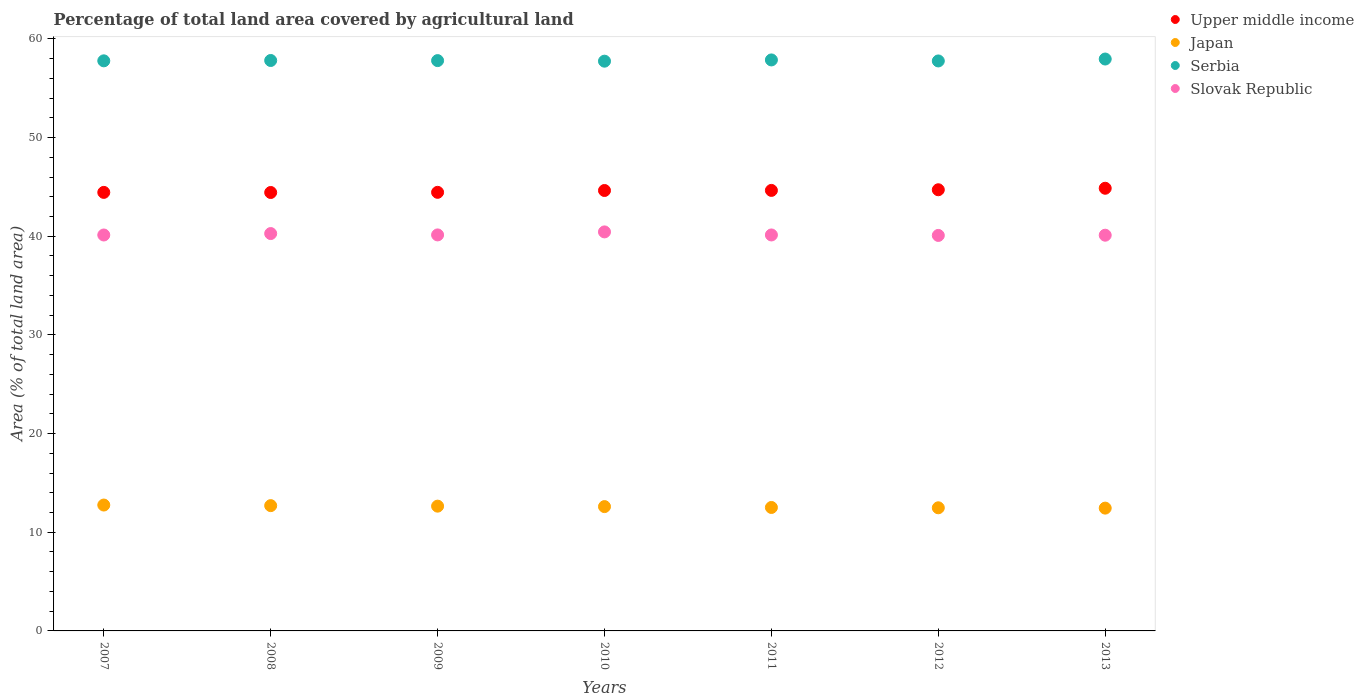How many different coloured dotlines are there?
Your answer should be compact. 4. What is the percentage of agricultural land in Upper middle income in 2012?
Offer a very short reply. 44.71. Across all years, what is the maximum percentage of agricultural land in Serbia?
Keep it short and to the point. 57.96. Across all years, what is the minimum percentage of agricultural land in Japan?
Make the answer very short. 12.45. What is the total percentage of agricultural land in Upper middle income in the graph?
Your answer should be compact. 312.17. What is the difference between the percentage of agricultural land in Slovak Republic in 2007 and that in 2008?
Give a very brief answer. -0.15. What is the difference between the percentage of agricultural land in Slovak Republic in 2008 and the percentage of agricultural land in Upper middle income in 2012?
Your answer should be compact. -4.44. What is the average percentage of agricultural land in Serbia per year?
Provide a succinct answer. 57.82. In the year 2013, what is the difference between the percentage of agricultural land in Serbia and percentage of agricultural land in Slovak Republic?
Make the answer very short. 17.85. What is the ratio of the percentage of agricultural land in Upper middle income in 2009 to that in 2013?
Your answer should be very brief. 0.99. What is the difference between the highest and the second highest percentage of agricultural land in Upper middle income?
Offer a very short reply. 0.15. What is the difference between the highest and the lowest percentage of agricultural land in Slovak Republic?
Give a very brief answer. 0.36. Is it the case that in every year, the sum of the percentage of agricultural land in Slovak Republic and percentage of agricultural land in Japan  is greater than the sum of percentage of agricultural land in Serbia and percentage of agricultural land in Upper middle income?
Make the answer very short. No. Does the percentage of agricultural land in Serbia monotonically increase over the years?
Keep it short and to the point. No. Is the percentage of agricultural land in Upper middle income strictly greater than the percentage of agricultural land in Serbia over the years?
Offer a very short reply. No. Is the percentage of agricultural land in Upper middle income strictly less than the percentage of agricultural land in Japan over the years?
Offer a very short reply. No. How many dotlines are there?
Make the answer very short. 4. What is the difference between two consecutive major ticks on the Y-axis?
Offer a very short reply. 10. Where does the legend appear in the graph?
Offer a very short reply. Top right. How many legend labels are there?
Provide a short and direct response. 4. What is the title of the graph?
Your answer should be very brief. Percentage of total land area covered by agricultural land. Does "Macedonia" appear as one of the legend labels in the graph?
Give a very brief answer. No. What is the label or title of the X-axis?
Your response must be concise. Years. What is the label or title of the Y-axis?
Give a very brief answer. Area (% of total land area). What is the Area (% of total land area) of Upper middle income in 2007?
Your answer should be compact. 44.44. What is the Area (% of total land area) in Japan in 2007?
Make the answer very short. 12.76. What is the Area (% of total land area) of Serbia in 2007?
Your answer should be compact. 57.77. What is the Area (% of total land area) of Slovak Republic in 2007?
Provide a succinct answer. 40.12. What is the Area (% of total land area) in Upper middle income in 2008?
Provide a succinct answer. 44.43. What is the Area (% of total land area) of Japan in 2008?
Your response must be concise. 12.7. What is the Area (% of total land area) of Serbia in 2008?
Offer a very short reply. 57.81. What is the Area (% of total land area) of Slovak Republic in 2008?
Your answer should be very brief. 40.27. What is the Area (% of total land area) of Upper middle income in 2009?
Ensure brevity in your answer.  44.45. What is the Area (% of total land area) in Japan in 2009?
Provide a short and direct response. 12.64. What is the Area (% of total land area) in Serbia in 2009?
Ensure brevity in your answer.  57.8. What is the Area (% of total land area) in Slovak Republic in 2009?
Your answer should be very brief. 40.13. What is the Area (% of total land area) in Upper middle income in 2010?
Make the answer very short. 44.63. What is the Area (% of total land area) of Japan in 2010?
Offer a very short reply. 12.6. What is the Area (% of total land area) in Serbia in 2010?
Your answer should be very brief. 57.74. What is the Area (% of total land area) of Slovak Republic in 2010?
Your response must be concise. 40.44. What is the Area (% of total land area) of Upper middle income in 2011?
Your answer should be very brief. 44.64. What is the Area (% of total land area) of Japan in 2011?
Offer a terse response. 12.51. What is the Area (% of total land area) of Serbia in 2011?
Keep it short and to the point. 57.87. What is the Area (% of total land area) of Slovak Republic in 2011?
Your answer should be very brief. 40.13. What is the Area (% of total land area) of Upper middle income in 2012?
Give a very brief answer. 44.71. What is the Area (% of total land area) in Japan in 2012?
Ensure brevity in your answer.  12.48. What is the Area (% of total land area) of Serbia in 2012?
Ensure brevity in your answer.  57.76. What is the Area (% of total land area) in Slovak Republic in 2012?
Ensure brevity in your answer.  40.08. What is the Area (% of total land area) of Upper middle income in 2013?
Give a very brief answer. 44.86. What is the Area (% of total land area) of Japan in 2013?
Offer a very short reply. 12.45. What is the Area (% of total land area) of Serbia in 2013?
Provide a succinct answer. 57.96. What is the Area (% of total land area) of Slovak Republic in 2013?
Make the answer very short. 40.1. Across all years, what is the maximum Area (% of total land area) in Upper middle income?
Provide a succinct answer. 44.86. Across all years, what is the maximum Area (% of total land area) in Japan?
Offer a very short reply. 12.76. Across all years, what is the maximum Area (% of total land area) in Serbia?
Provide a short and direct response. 57.96. Across all years, what is the maximum Area (% of total land area) of Slovak Republic?
Keep it short and to the point. 40.44. Across all years, what is the minimum Area (% of total land area) of Upper middle income?
Give a very brief answer. 44.43. Across all years, what is the minimum Area (% of total land area) in Japan?
Ensure brevity in your answer.  12.45. Across all years, what is the minimum Area (% of total land area) in Serbia?
Ensure brevity in your answer.  57.74. Across all years, what is the minimum Area (% of total land area) of Slovak Republic?
Ensure brevity in your answer.  40.08. What is the total Area (% of total land area) in Upper middle income in the graph?
Provide a succinct answer. 312.17. What is the total Area (% of total land area) of Japan in the graph?
Keep it short and to the point. 88.13. What is the total Area (% of total land area) of Serbia in the graph?
Make the answer very short. 404.71. What is the total Area (% of total land area) of Slovak Republic in the graph?
Ensure brevity in your answer.  281.28. What is the difference between the Area (% of total land area) in Upper middle income in 2007 and that in 2008?
Provide a short and direct response. 0.01. What is the difference between the Area (% of total land area) of Japan in 2007 and that in 2008?
Your answer should be compact. 0.06. What is the difference between the Area (% of total land area) in Serbia in 2007 and that in 2008?
Your answer should be compact. -0.03. What is the difference between the Area (% of total land area) of Slovak Republic in 2007 and that in 2008?
Keep it short and to the point. -0.15. What is the difference between the Area (% of total land area) in Upper middle income in 2007 and that in 2009?
Provide a succinct answer. -0.01. What is the difference between the Area (% of total land area) in Japan in 2007 and that in 2009?
Provide a short and direct response. 0.11. What is the difference between the Area (% of total land area) of Serbia in 2007 and that in 2009?
Your response must be concise. -0.02. What is the difference between the Area (% of total land area) in Slovak Republic in 2007 and that in 2009?
Keep it short and to the point. -0.01. What is the difference between the Area (% of total land area) in Upper middle income in 2007 and that in 2010?
Offer a terse response. -0.19. What is the difference between the Area (% of total land area) in Japan in 2007 and that in 2010?
Give a very brief answer. 0.16. What is the difference between the Area (% of total land area) in Serbia in 2007 and that in 2010?
Your response must be concise. 0.03. What is the difference between the Area (% of total land area) in Slovak Republic in 2007 and that in 2010?
Your response must be concise. -0.31. What is the difference between the Area (% of total land area) of Upper middle income in 2007 and that in 2011?
Provide a succinct answer. -0.2. What is the difference between the Area (% of total land area) in Japan in 2007 and that in 2011?
Ensure brevity in your answer.  0.25. What is the difference between the Area (% of total land area) of Serbia in 2007 and that in 2011?
Your answer should be compact. -0.09. What is the difference between the Area (% of total land area) of Slovak Republic in 2007 and that in 2011?
Provide a succinct answer. -0. What is the difference between the Area (% of total land area) of Upper middle income in 2007 and that in 2012?
Your response must be concise. -0.27. What is the difference between the Area (% of total land area) of Japan in 2007 and that in 2012?
Offer a terse response. 0.28. What is the difference between the Area (% of total land area) in Serbia in 2007 and that in 2012?
Give a very brief answer. 0.01. What is the difference between the Area (% of total land area) in Slovak Republic in 2007 and that in 2012?
Your response must be concise. 0.04. What is the difference between the Area (% of total land area) in Upper middle income in 2007 and that in 2013?
Ensure brevity in your answer.  -0.42. What is the difference between the Area (% of total land area) in Japan in 2007 and that in 2013?
Offer a very short reply. 0.31. What is the difference between the Area (% of total land area) in Serbia in 2007 and that in 2013?
Your answer should be very brief. -0.18. What is the difference between the Area (% of total land area) in Slovak Republic in 2007 and that in 2013?
Make the answer very short. 0.02. What is the difference between the Area (% of total land area) of Upper middle income in 2008 and that in 2009?
Provide a succinct answer. -0.02. What is the difference between the Area (% of total land area) in Japan in 2008 and that in 2009?
Provide a succinct answer. 0.05. What is the difference between the Area (% of total land area) of Serbia in 2008 and that in 2009?
Your answer should be very brief. 0.01. What is the difference between the Area (% of total land area) in Slovak Republic in 2008 and that in 2009?
Your answer should be very brief. 0.14. What is the difference between the Area (% of total land area) in Upper middle income in 2008 and that in 2010?
Offer a very short reply. -0.2. What is the difference between the Area (% of total land area) of Japan in 2008 and that in 2010?
Keep it short and to the point. 0.1. What is the difference between the Area (% of total land area) in Serbia in 2008 and that in 2010?
Offer a very short reply. 0.07. What is the difference between the Area (% of total land area) in Slovak Republic in 2008 and that in 2010?
Give a very brief answer. -0.17. What is the difference between the Area (% of total land area) of Upper middle income in 2008 and that in 2011?
Your answer should be very brief. -0.21. What is the difference between the Area (% of total land area) of Japan in 2008 and that in 2011?
Ensure brevity in your answer.  0.19. What is the difference between the Area (% of total land area) in Serbia in 2008 and that in 2011?
Give a very brief answer. -0.06. What is the difference between the Area (% of total land area) of Slovak Republic in 2008 and that in 2011?
Your answer should be very brief. 0.14. What is the difference between the Area (% of total land area) of Upper middle income in 2008 and that in 2012?
Give a very brief answer. -0.28. What is the difference between the Area (% of total land area) in Japan in 2008 and that in 2012?
Your answer should be compact. 0.22. What is the difference between the Area (% of total land area) in Serbia in 2008 and that in 2012?
Give a very brief answer. 0.05. What is the difference between the Area (% of total land area) in Slovak Republic in 2008 and that in 2012?
Your answer should be very brief. 0.19. What is the difference between the Area (% of total land area) in Upper middle income in 2008 and that in 2013?
Provide a short and direct response. -0.43. What is the difference between the Area (% of total land area) of Japan in 2008 and that in 2013?
Offer a terse response. 0.25. What is the difference between the Area (% of total land area) in Serbia in 2008 and that in 2013?
Your answer should be very brief. -0.15. What is the difference between the Area (% of total land area) of Slovak Republic in 2008 and that in 2013?
Offer a very short reply. 0.17. What is the difference between the Area (% of total land area) of Upper middle income in 2009 and that in 2010?
Make the answer very short. -0.19. What is the difference between the Area (% of total land area) of Japan in 2009 and that in 2010?
Provide a succinct answer. 0.05. What is the difference between the Area (% of total land area) of Serbia in 2009 and that in 2010?
Offer a terse response. 0.06. What is the difference between the Area (% of total land area) of Slovak Republic in 2009 and that in 2010?
Give a very brief answer. -0.3. What is the difference between the Area (% of total land area) in Upper middle income in 2009 and that in 2011?
Ensure brevity in your answer.  -0.2. What is the difference between the Area (% of total land area) of Japan in 2009 and that in 2011?
Your answer should be compact. 0.13. What is the difference between the Area (% of total land area) in Serbia in 2009 and that in 2011?
Offer a very short reply. -0.07. What is the difference between the Area (% of total land area) in Slovak Republic in 2009 and that in 2011?
Ensure brevity in your answer.  0. What is the difference between the Area (% of total land area) in Upper middle income in 2009 and that in 2012?
Offer a very short reply. -0.26. What is the difference between the Area (% of total land area) of Serbia in 2009 and that in 2012?
Your answer should be compact. 0.03. What is the difference between the Area (% of total land area) in Slovak Republic in 2009 and that in 2012?
Give a very brief answer. 0.05. What is the difference between the Area (% of total land area) in Upper middle income in 2009 and that in 2013?
Your response must be concise. -0.41. What is the difference between the Area (% of total land area) of Japan in 2009 and that in 2013?
Ensure brevity in your answer.  0.2. What is the difference between the Area (% of total land area) in Serbia in 2009 and that in 2013?
Ensure brevity in your answer.  -0.16. What is the difference between the Area (% of total land area) in Slovak Republic in 2009 and that in 2013?
Your answer should be very brief. 0.03. What is the difference between the Area (% of total land area) in Upper middle income in 2010 and that in 2011?
Offer a terse response. -0.01. What is the difference between the Area (% of total land area) of Japan in 2010 and that in 2011?
Keep it short and to the point. 0.09. What is the difference between the Area (% of total land area) of Serbia in 2010 and that in 2011?
Offer a very short reply. -0.13. What is the difference between the Area (% of total land area) of Slovak Republic in 2010 and that in 2011?
Make the answer very short. 0.31. What is the difference between the Area (% of total land area) of Upper middle income in 2010 and that in 2012?
Your response must be concise. -0.08. What is the difference between the Area (% of total land area) of Japan in 2010 and that in 2012?
Provide a short and direct response. 0.12. What is the difference between the Area (% of total land area) of Serbia in 2010 and that in 2012?
Ensure brevity in your answer.  -0.02. What is the difference between the Area (% of total land area) in Slovak Republic in 2010 and that in 2012?
Your response must be concise. 0.36. What is the difference between the Area (% of total land area) of Upper middle income in 2010 and that in 2013?
Offer a very short reply. -0.23. What is the difference between the Area (% of total land area) in Japan in 2010 and that in 2013?
Keep it short and to the point. 0.15. What is the difference between the Area (% of total land area) in Serbia in 2010 and that in 2013?
Give a very brief answer. -0.22. What is the difference between the Area (% of total land area) of Slovak Republic in 2010 and that in 2013?
Your answer should be compact. 0.33. What is the difference between the Area (% of total land area) of Upper middle income in 2011 and that in 2012?
Provide a short and direct response. -0.07. What is the difference between the Area (% of total land area) of Japan in 2011 and that in 2012?
Ensure brevity in your answer.  0.03. What is the difference between the Area (% of total land area) in Serbia in 2011 and that in 2012?
Ensure brevity in your answer.  0.1. What is the difference between the Area (% of total land area) of Slovak Republic in 2011 and that in 2012?
Your response must be concise. 0.05. What is the difference between the Area (% of total land area) of Upper middle income in 2011 and that in 2013?
Your response must be concise. -0.22. What is the difference between the Area (% of total land area) in Japan in 2011 and that in 2013?
Make the answer very short. 0.07. What is the difference between the Area (% of total land area) in Serbia in 2011 and that in 2013?
Give a very brief answer. -0.09. What is the difference between the Area (% of total land area) in Slovak Republic in 2011 and that in 2013?
Give a very brief answer. 0.03. What is the difference between the Area (% of total land area) in Upper middle income in 2012 and that in 2013?
Make the answer very short. -0.15. What is the difference between the Area (% of total land area) of Japan in 2012 and that in 2013?
Your response must be concise. 0.03. What is the difference between the Area (% of total land area) in Serbia in 2012 and that in 2013?
Provide a short and direct response. -0.19. What is the difference between the Area (% of total land area) in Slovak Republic in 2012 and that in 2013?
Keep it short and to the point. -0.02. What is the difference between the Area (% of total land area) of Upper middle income in 2007 and the Area (% of total land area) of Japan in 2008?
Keep it short and to the point. 31.75. What is the difference between the Area (% of total land area) of Upper middle income in 2007 and the Area (% of total land area) of Serbia in 2008?
Your answer should be very brief. -13.37. What is the difference between the Area (% of total land area) of Upper middle income in 2007 and the Area (% of total land area) of Slovak Republic in 2008?
Provide a short and direct response. 4.17. What is the difference between the Area (% of total land area) in Japan in 2007 and the Area (% of total land area) in Serbia in 2008?
Your answer should be very brief. -45.05. What is the difference between the Area (% of total land area) in Japan in 2007 and the Area (% of total land area) in Slovak Republic in 2008?
Your response must be concise. -27.51. What is the difference between the Area (% of total land area) of Serbia in 2007 and the Area (% of total land area) of Slovak Republic in 2008?
Your answer should be very brief. 17.5. What is the difference between the Area (% of total land area) in Upper middle income in 2007 and the Area (% of total land area) in Japan in 2009?
Provide a short and direct response. 31.8. What is the difference between the Area (% of total land area) of Upper middle income in 2007 and the Area (% of total land area) of Serbia in 2009?
Provide a succinct answer. -13.35. What is the difference between the Area (% of total land area) in Upper middle income in 2007 and the Area (% of total land area) in Slovak Republic in 2009?
Offer a very short reply. 4.31. What is the difference between the Area (% of total land area) of Japan in 2007 and the Area (% of total land area) of Serbia in 2009?
Your answer should be compact. -45.04. What is the difference between the Area (% of total land area) of Japan in 2007 and the Area (% of total land area) of Slovak Republic in 2009?
Your response must be concise. -27.38. What is the difference between the Area (% of total land area) in Serbia in 2007 and the Area (% of total land area) in Slovak Republic in 2009?
Provide a succinct answer. 17.64. What is the difference between the Area (% of total land area) in Upper middle income in 2007 and the Area (% of total land area) in Japan in 2010?
Give a very brief answer. 31.84. What is the difference between the Area (% of total land area) in Upper middle income in 2007 and the Area (% of total land area) in Serbia in 2010?
Ensure brevity in your answer.  -13.3. What is the difference between the Area (% of total land area) in Upper middle income in 2007 and the Area (% of total land area) in Slovak Republic in 2010?
Your answer should be very brief. 4.01. What is the difference between the Area (% of total land area) of Japan in 2007 and the Area (% of total land area) of Serbia in 2010?
Give a very brief answer. -44.98. What is the difference between the Area (% of total land area) of Japan in 2007 and the Area (% of total land area) of Slovak Republic in 2010?
Provide a succinct answer. -27.68. What is the difference between the Area (% of total land area) of Serbia in 2007 and the Area (% of total land area) of Slovak Republic in 2010?
Make the answer very short. 17.34. What is the difference between the Area (% of total land area) of Upper middle income in 2007 and the Area (% of total land area) of Japan in 2011?
Your response must be concise. 31.93. What is the difference between the Area (% of total land area) in Upper middle income in 2007 and the Area (% of total land area) in Serbia in 2011?
Ensure brevity in your answer.  -13.42. What is the difference between the Area (% of total land area) of Upper middle income in 2007 and the Area (% of total land area) of Slovak Republic in 2011?
Give a very brief answer. 4.31. What is the difference between the Area (% of total land area) in Japan in 2007 and the Area (% of total land area) in Serbia in 2011?
Your answer should be very brief. -45.11. What is the difference between the Area (% of total land area) in Japan in 2007 and the Area (% of total land area) in Slovak Republic in 2011?
Your response must be concise. -27.37. What is the difference between the Area (% of total land area) in Serbia in 2007 and the Area (% of total land area) in Slovak Republic in 2011?
Your answer should be very brief. 17.65. What is the difference between the Area (% of total land area) of Upper middle income in 2007 and the Area (% of total land area) of Japan in 2012?
Your response must be concise. 31.97. What is the difference between the Area (% of total land area) of Upper middle income in 2007 and the Area (% of total land area) of Serbia in 2012?
Offer a terse response. -13.32. What is the difference between the Area (% of total land area) in Upper middle income in 2007 and the Area (% of total land area) in Slovak Republic in 2012?
Make the answer very short. 4.36. What is the difference between the Area (% of total land area) in Japan in 2007 and the Area (% of total land area) in Serbia in 2012?
Ensure brevity in your answer.  -45.01. What is the difference between the Area (% of total land area) in Japan in 2007 and the Area (% of total land area) in Slovak Republic in 2012?
Your answer should be very brief. -27.32. What is the difference between the Area (% of total land area) of Serbia in 2007 and the Area (% of total land area) of Slovak Republic in 2012?
Make the answer very short. 17.69. What is the difference between the Area (% of total land area) of Upper middle income in 2007 and the Area (% of total land area) of Japan in 2013?
Your answer should be compact. 32. What is the difference between the Area (% of total land area) in Upper middle income in 2007 and the Area (% of total land area) in Serbia in 2013?
Offer a very short reply. -13.51. What is the difference between the Area (% of total land area) in Upper middle income in 2007 and the Area (% of total land area) in Slovak Republic in 2013?
Provide a succinct answer. 4.34. What is the difference between the Area (% of total land area) in Japan in 2007 and the Area (% of total land area) in Serbia in 2013?
Keep it short and to the point. -45.2. What is the difference between the Area (% of total land area) in Japan in 2007 and the Area (% of total land area) in Slovak Republic in 2013?
Ensure brevity in your answer.  -27.35. What is the difference between the Area (% of total land area) of Serbia in 2007 and the Area (% of total land area) of Slovak Republic in 2013?
Ensure brevity in your answer.  17.67. What is the difference between the Area (% of total land area) of Upper middle income in 2008 and the Area (% of total land area) of Japan in 2009?
Ensure brevity in your answer.  31.79. What is the difference between the Area (% of total land area) in Upper middle income in 2008 and the Area (% of total land area) in Serbia in 2009?
Offer a terse response. -13.37. What is the difference between the Area (% of total land area) in Upper middle income in 2008 and the Area (% of total land area) in Slovak Republic in 2009?
Offer a terse response. 4.3. What is the difference between the Area (% of total land area) in Japan in 2008 and the Area (% of total land area) in Serbia in 2009?
Ensure brevity in your answer.  -45.1. What is the difference between the Area (% of total land area) in Japan in 2008 and the Area (% of total land area) in Slovak Republic in 2009?
Make the answer very short. -27.44. What is the difference between the Area (% of total land area) of Serbia in 2008 and the Area (% of total land area) of Slovak Republic in 2009?
Your answer should be very brief. 17.68. What is the difference between the Area (% of total land area) of Upper middle income in 2008 and the Area (% of total land area) of Japan in 2010?
Provide a short and direct response. 31.83. What is the difference between the Area (% of total land area) in Upper middle income in 2008 and the Area (% of total land area) in Serbia in 2010?
Offer a terse response. -13.31. What is the difference between the Area (% of total land area) in Upper middle income in 2008 and the Area (% of total land area) in Slovak Republic in 2010?
Provide a short and direct response. 3.99. What is the difference between the Area (% of total land area) of Japan in 2008 and the Area (% of total land area) of Serbia in 2010?
Make the answer very short. -45.04. What is the difference between the Area (% of total land area) in Japan in 2008 and the Area (% of total land area) in Slovak Republic in 2010?
Keep it short and to the point. -27.74. What is the difference between the Area (% of total land area) in Serbia in 2008 and the Area (% of total land area) in Slovak Republic in 2010?
Give a very brief answer. 17.37. What is the difference between the Area (% of total land area) of Upper middle income in 2008 and the Area (% of total land area) of Japan in 2011?
Your answer should be very brief. 31.92. What is the difference between the Area (% of total land area) in Upper middle income in 2008 and the Area (% of total land area) in Serbia in 2011?
Your answer should be very brief. -13.43. What is the difference between the Area (% of total land area) in Upper middle income in 2008 and the Area (% of total land area) in Slovak Republic in 2011?
Your answer should be very brief. 4.3. What is the difference between the Area (% of total land area) in Japan in 2008 and the Area (% of total land area) in Serbia in 2011?
Offer a very short reply. -45.17. What is the difference between the Area (% of total land area) in Japan in 2008 and the Area (% of total land area) in Slovak Republic in 2011?
Provide a succinct answer. -27.43. What is the difference between the Area (% of total land area) of Serbia in 2008 and the Area (% of total land area) of Slovak Republic in 2011?
Offer a terse response. 17.68. What is the difference between the Area (% of total land area) of Upper middle income in 2008 and the Area (% of total land area) of Japan in 2012?
Give a very brief answer. 31.95. What is the difference between the Area (% of total land area) of Upper middle income in 2008 and the Area (% of total land area) of Serbia in 2012?
Give a very brief answer. -13.33. What is the difference between the Area (% of total land area) in Upper middle income in 2008 and the Area (% of total land area) in Slovak Republic in 2012?
Ensure brevity in your answer.  4.35. What is the difference between the Area (% of total land area) of Japan in 2008 and the Area (% of total land area) of Serbia in 2012?
Your answer should be compact. -45.07. What is the difference between the Area (% of total land area) in Japan in 2008 and the Area (% of total land area) in Slovak Republic in 2012?
Give a very brief answer. -27.38. What is the difference between the Area (% of total land area) in Serbia in 2008 and the Area (% of total land area) in Slovak Republic in 2012?
Ensure brevity in your answer.  17.73. What is the difference between the Area (% of total land area) in Upper middle income in 2008 and the Area (% of total land area) in Japan in 2013?
Keep it short and to the point. 31.99. What is the difference between the Area (% of total land area) in Upper middle income in 2008 and the Area (% of total land area) in Serbia in 2013?
Make the answer very short. -13.53. What is the difference between the Area (% of total land area) in Upper middle income in 2008 and the Area (% of total land area) in Slovak Republic in 2013?
Offer a terse response. 4.33. What is the difference between the Area (% of total land area) of Japan in 2008 and the Area (% of total land area) of Serbia in 2013?
Your response must be concise. -45.26. What is the difference between the Area (% of total land area) of Japan in 2008 and the Area (% of total land area) of Slovak Republic in 2013?
Give a very brief answer. -27.41. What is the difference between the Area (% of total land area) of Serbia in 2008 and the Area (% of total land area) of Slovak Republic in 2013?
Keep it short and to the point. 17.71. What is the difference between the Area (% of total land area) in Upper middle income in 2009 and the Area (% of total land area) in Japan in 2010?
Give a very brief answer. 31.85. What is the difference between the Area (% of total land area) of Upper middle income in 2009 and the Area (% of total land area) of Serbia in 2010?
Provide a succinct answer. -13.29. What is the difference between the Area (% of total land area) in Upper middle income in 2009 and the Area (% of total land area) in Slovak Republic in 2010?
Offer a very short reply. 4.01. What is the difference between the Area (% of total land area) in Japan in 2009 and the Area (% of total land area) in Serbia in 2010?
Make the answer very short. -45.1. What is the difference between the Area (% of total land area) of Japan in 2009 and the Area (% of total land area) of Slovak Republic in 2010?
Your answer should be compact. -27.79. What is the difference between the Area (% of total land area) of Serbia in 2009 and the Area (% of total land area) of Slovak Republic in 2010?
Offer a terse response. 17.36. What is the difference between the Area (% of total land area) in Upper middle income in 2009 and the Area (% of total land area) in Japan in 2011?
Keep it short and to the point. 31.94. What is the difference between the Area (% of total land area) of Upper middle income in 2009 and the Area (% of total land area) of Serbia in 2011?
Offer a terse response. -13.42. What is the difference between the Area (% of total land area) of Upper middle income in 2009 and the Area (% of total land area) of Slovak Republic in 2011?
Your response must be concise. 4.32. What is the difference between the Area (% of total land area) of Japan in 2009 and the Area (% of total land area) of Serbia in 2011?
Your answer should be very brief. -45.22. What is the difference between the Area (% of total land area) in Japan in 2009 and the Area (% of total land area) in Slovak Republic in 2011?
Offer a very short reply. -27.48. What is the difference between the Area (% of total land area) of Serbia in 2009 and the Area (% of total land area) of Slovak Republic in 2011?
Keep it short and to the point. 17.67. What is the difference between the Area (% of total land area) of Upper middle income in 2009 and the Area (% of total land area) of Japan in 2012?
Your answer should be compact. 31.97. What is the difference between the Area (% of total land area) in Upper middle income in 2009 and the Area (% of total land area) in Serbia in 2012?
Offer a very short reply. -13.31. What is the difference between the Area (% of total land area) of Upper middle income in 2009 and the Area (% of total land area) of Slovak Republic in 2012?
Ensure brevity in your answer.  4.37. What is the difference between the Area (% of total land area) of Japan in 2009 and the Area (% of total land area) of Serbia in 2012?
Your answer should be compact. -45.12. What is the difference between the Area (% of total land area) of Japan in 2009 and the Area (% of total land area) of Slovak Republic in 2012?
Give a very brief answer. -27.44. What is the difference between the Area (% of total land area) in Serbia in 2009 and the Area (% of total land area) in Slovak Republic in 2012?
Offer a terse response. 17.72. What is the difference between the Area (% of total land area) in Upper middle income in 2009 and the Area (% of total land area) in Japan in 2013?
Offer a terse response. 32. What is the difference between the Area (% of total land area) in Upper middle income in 2009 and the Area (% of total land area) in Serbia in 2013?
Offer a very short reply. -13.51. What is the difference between the Area (% of total land area) in Upper middle income in 2009 and the Area (% of total land area) in Slovak Republic in 2013?
Your answer should be compact. 4.35. What is the difference between the Area (% of total land area) of Japan in 2009 and the Area (% of total land area) of Serbia in 2013?
Provide a short and direct response. -45.31. What is the difference between the Area (% of total land area) in Japan in 2009 and the Area (% of total land area) in Slovak Republic in 2013?
Ensure brevity in your answer.  -27.46. What is the difference between the Area (% of total land area) of Serbia in 2009 and the Area (% of total land area) of Slovak Republic in 2013?
Ensure brevity in your answer.  17.69. What is the difference between the Area (% of total land area) of Upper middle income in 2010 and the Area (% of total land area) of Japan in 2011?
Offer a terse response. 32.12. What is the difference between the Area (% of total land area) of Upper middle income in 2010 and the Area (% of total land area) of Serbia in 2011?
Your answer should be compact. -13.23. What is the difference between the Area (% of total land area) of Upper middle income in 2010 and the Area (% of total land area) of Slovak Republic in 2011?
Give a very brief answer. 4.51. What is the difference between the Area (% of total land area) of Japan in 2010 and the Area (% of total land area) of Serbia in 2011?
Offer a terse response. -45.27. What is the difference between the Area (% of total land area) of Japan in 2010 and the Area (% of total land area) of Slovak Republic in 2011?
Offer a terse response. -27.53. What is the difference between the Area (% of total land area) in Serbia in 2010 and the Area (% of total land area) in Slovak Republic in 2011?
Provide a short and direct response. 17.61. What is the difference between the Area (% of total land area) in Upper middle income in 2010 and the Area (% of total land area) in Japan in 2012?
Make the answer very short. 32.16. What is the difference between the Area (% of total land area) of Upper middle income in 2010 and the Area (% of total land area) of Serbia in 2012?
Your response must be concise. -13.13. What is the difference between the Area (% of total land area) in Upper middle income in 2010 and the Area (% of total land area) in Slovak Republic in 2012?
Your response must be concise. 4.55. What is the difference between the Area (% of total land area) in Japan in 2010 and the Area (% of total land area) in Serbia in 2012?
Provide a short and direct response. -45.16. What is the difference between the Area (% of total land area) of Japan in 2010 and the Area (% of total land area) of Slovak Republic in 2012?
Make the answer very short. -27.48. What is the difference between the Area (% of total land area) of Serbia in 2010 and the Area (% of total land area) of Slovak Republic in 2012?
Offer a terse response. 17.66. What is the difference between the Area (% of total land area) in Upper middle income in 2010 and the Area (% of total land area) in Japan in 2013?
Offer a very short reply. 32.19. What is the difference between the Area (% of total land area) of Upper middle income in 2010 and the Area (% of total land area) of Serbia in 2013?
Your response must be concise. -13.32. What is the difference between the Area (% of total land area) in Upper middle income in 2010 and the Area (% of total land area) in Slovak Republic in 2013?
Offer a terse response. 4.53. What is the difference between the Area (% of total land area) of Japan in 2010 and the Area (% of total land area) of Serbia in 2013?
Keep it short and to the point. -45.36. What is the difference between the Area (% of total land area) of Japan in 2010 and the Area (% of total land area) of Slovak Republic in 2013?
Give a very brief answer. -27.5. What is the difference between the Area (% of total land area) of Serbia in 2010 and the Area (% of total land area) of Slovak Republic in 2013?
Provide a succinct answer. 17.64. What is the difference between the Area (% of total land area) of Upper middle income in 2011 and the Area (% of total land area) of Japan in 2012?
Ensure brevity in your answer.  32.17. What is the difference between the Area (% of total land area) in Upper middle income in 2011 and the Area (% of total land area) in Serbia in 2012?
Offer a very short reply. -13.12. What is the difference between the Area (% of total land area) in Upper middle income in 2011 and the Area (% of total land area) in Slovak Republic in 2012?
Provide a short and direct response. 4.56. What is the difference between the Area (% of total land area) in Japan in 2011 and the Area (% of total land area) in Serbia in 2012?
Provide a succinct answer. -45.25. What is the difference between the Area (% of total land area) of Japan in 2011 and the Area (% of total land area) of Slovak Republic in 2012?
Make the answer very short. -27.57. What is the difference between the Area (% of total land area) in Serbia in 2011 and the Area (% of total land area) in Slovak Republic in 2012?
Your answer should be compact. 17.79. What is the difference between the Area (% of total land area) in Upper middle income in 2011 and the Area (% of total land area) in Japan in 2013?
Offer a terse response. 32.2. What is the difference between the Area (% of total land area) in Upper middle income in 2011 and the Area (% of total land area) in Serbia in 2013?
Provide a short and direct response. -13.31. What is the difference between the Area (% of total land area) of Upper middle income in 2011 and the Area (% of total land area) of Slovak Republic in 2013?
Your response must be concise. 4.54. What is the difference between the Area (% of total land area) in Japan in 2011 and the Area (% of total land area) in Serbia in 2013?
Make the answer very short. -45.45. What is the difference between the Area (% of total land area) in Japan in 2011 and the Area (% of total land area) in Slovak Republic in 2013?
Offer a terse response. -27.59. What is the difference between the Area (% of total land area) in Serbia in 2011 and the Area (% of total land area) in Slovak Republic in 2013?
Give a very brief answer. 17.76. What is the difference between the Area (% of total land area) in Upper middle income in 2012 and the Area (% of total land area) in Japan in 2013?
Make the answer very short. 32.26. What is the difference between the Area (% of total land area) in Upper middle income in 2012 and the Area (% of total land area) in Serbia in 2013?
Offer a very short reply. -13.25. What is the difference between the Area (% of total land area) in Upper middle income in 2012 and the Area (% of total land area) in Slovak Republic in 2013?
Offer a very short reply. 4.61. What is the difference between the Area (% of total land area) in Japan in 2012 and the Area (% of total land area) in Serbia in 2013?
Provide a succinct answer. -45.48. What is the difference between the Area (% of total land area) in Japan in 2012 and the Area (% of total land area) in Slovak Republic in 2013?
Your answer should be very brief. -27.63. What is the difference between the Area (% of total land area) in Serbia in 2012 and the Area (% of total land area) in Slovak Republic in 2013?
Your response must be concise. 17.66. What is the average Area (% of total land area) of Upper middle income per year?
Your answer should be very brief. 44.6. What is the average Area (% of total land area) in Japan per year?
Provide a short and direct response. 12.59. What is the average Area (% of total land area) of Serbia per year?
Ensure brevity in your answer.  57.82. What is the average Area (% of total land area) of Slovak Republic per year?
Give a very brief answer. 40.18. In the year 2007, what is the difference between the Area (% of total land area) of Upper middle income and Area (% of total land area) of Japan?
Make the answer very short. 31.69. In the year 2007, what is the difference between the Area (% of total land area) of Upper middle income and Area (% of total land area) of Serbia?
Keep it short and to the point. -13.33. In the year 2007, what is the difference between the Area (% of total land area) of Upper middle income and Area (% of total land area) of Slovak Republic?
Your response must be concise. 4.32. In the year 2007, what is the difference between the Area (% of total land area) of Japan and Area (% of total land area) of Serbia?
Ensure brevity in your answer.  -45.02. In the year 2007, what is the difference between the Area (% of total land area) in Japan and Area (% of total land area) in Slovak Republic?
Your response must be concise. -27.37. In the year 2007, what is the difference between the Area (% of total land area) in Serbia and Area (% of total land area) in Slovak Republic?
Provide a short and direct response. 17.65. In the year 2008, what is the difference between the Area (% of total land area) of Upper middle income and Area (% of total land area) of Japan?
Make the answer very short. 31.74. In the year 2008, what is the difference between the Area (% of total land area) of Upper middle income and Area (% of total land area) of Serbia?
Your answer should be very brief. -13.38. In the year 2008, what is the difference between the Area (% of total land area) of Upper middle income and Area (% of total land area) of Slovak Republic?
Give a very brief answer. 4.16. In the year 2008, what is the difference between the Area (% of total land area) of Japan and Area (% of total land area) of Serbia?
Give a very brief answer. -45.11. In the year 2008, what is the difference between the Area (% of total land area) of Japan and Area (% of total land area) of Slovak Republic?
Give a very brief answer. -27.57. In the year 2008, what is the difference between the Area (% of total land area) in Serbia and Area (% of total land area) in Slovak Republic?
Keep it short and to the point. 17.54. In the year 2009, what is the difference between the Area (% of total land area) in Upper middle income and Area (% of total land area) in Japan?
Offer a terse response. 31.8. In the year 2009, what is the difference between the Area (% of total land area) in Upper middle income and Area (% of total land area) in Serbia?
Offer a very short reply. -13.35. In the year 2009, what is the difference between the Area (% of total land area) of Upper middle income and Area (% of total land area) of Slovak Republic?
Offer a terse response. 4.32. In the year 2009, what is the difference between the Area (% of total land area) of Japan and Area (% of total land area) of Serbia?
Keep it short and to the point. -45.15. In the year 2009, what is the difference between the Area (% of total land area) of Japan and Area (% of total land area) of Slovak Republic?
Give a very brief answer. -27.49. In the year 2009, what is the difference between the Area (% of total land area) of Serbia and Area (% of total land area) of Slovak Republic?
Your answer should be very brief. 17.66. In the year 2010, what is the difference between the Area (% of total land area) of Upper middle income and Area (% of total land area) of Japan?
Provide a short and direct response. 32.04. In the year 2010, what is the difference between the Area (% of total land area) in Upper middle income and Area (% of total land area) in Serbia?
Your answer should be very brief. -13.11. In the year 2010, what is the difference between the Area (% of total land area) of Upper middle income and Area (% of total land area) of Slovak Republic?
Make the answer very short. 4.2. In the year 2010, what is the difference between the Area (% of total land area) of Japan and Area (% of total land area) of Serbia?
Offer a terse response. -45.14. In the year 2010, what is the difference between the Area (% of total land area) of Japan and Area (% of total land area) of Slovak Republic?
Make the answer very short. -27.84. In the year 2010, what is the difference between the Area (% of total land area) in Serbia and Area (% of total land area) in Slovak Republic?
Your response must be concise. 17.3. In the year 2011, what is the difference between the Area (% of total land area) of Upper middle income and Area (% of total land area) of Japan?
Offer a terse response. 32.13. In the year 2011, what is the difference between the Area (% of total land area) of Upper middle income and Area (% of total land area) of Serbia?
Provide a succinct answer. -13.22. In the year 2011, what is the difference between the Area (% of total land area) in Upper middle income and Area (% of total land area) in Slovak Republic?
Keep it short and to the point. 4.52. In the year 2011, what is the difference between the Area (% of total land area) of Japan and Area (% of total land area) of Serbia?
Your answer should be compact. -45.36. In the year 2011, what is the difference between the Area (% of total land area) of Japan and Area (% of total land area) of Slovak Republic?
Provide a short and direct response. -27.62. In the year 2011, what is the difference between the Area (% of total land area) in Serbia and Area (% of total land area) in Slovak Republic?
Your answer should be very brief. 17.74. In the year 2012, what is the difference between the Area (% of total land area) of Upper middle income and Area (% of total land area) of Japan?
Provide a succinct answer. 32.23. In the year 2012, what is the difference between the Area (% of total land area) of Upper middle income and Area (% of total land area) of Serbia?
Ensure brevity in your answer.  -13.05. In the year 2012, what is the difference between the Area (% of total land area) of Upper middle income and Area (% of total land area) of Slovak Republic?
Ensure brevity in your answer.  4.63. In the year 2012, what is the difference between the Area (% of total land area) in Japan and Area (% of total land area) in Serbia?
Offer a very short reply. -45.29. In the year 2012, what is the difference between the Area (% of total land area) of Japan and Area (% of total land area) of Slovak Republic?
Your answer should be compact. -27.6. In the year 2012, what is the difference between the Area (% of total land area) of Serbia and Area (% of total land area) of Slovak Republic?
Provide a short and direct response. 17.68. In the year 2013, what is the difference between the Area (% of total land area) of Upper middle income and Area (% of total land area) of Japan?
Provide a short and direct response. 32.42. In the year 2013, what is the difference between the Area (% of total land area) in Upper middle income and Area (% of total land area) in Serbia?
Your response must be concise. -13.1. In the year 2013, what is the difference between the Area (% of total land area) in Upper middle income and Area (% of total land area) in Slovak Republic?
Keep it short and to the point. 4.76. In the year 2013, what is the difference between the Area (% of total land area) of Japan and Area (% of total land area) of Serbia?
Ensure brevity in your answer.  -45.51. In the year 2013, what is the difference between the Area (% of total land area) in Japan and Area (% of total land area) in Slovak Republic?
Ensure brevity in your answer.  -27.66. In the year 2013, what is the difference between the Area (% of total land area) in Serbia and Area (% of total land area) in Slovak Republic?
Provide a short and direct response. 17.85. What is the ratio of the Area (% of total land area) in Japan in 2007 to that in 2008?
Keep it short and to the point. 1. What is the ratio of the Area (% of total land area) of Serbia in 2007 to that in 2008?
Give a very brief answer. 1. What is the ratio of the Area (% of total land area) in Japan in 2007 to that in 2009?
Offer a very short reply. 1.01. What is the ratio of the Area (% of total land area) in Serbia in 2007 to that in 2009?
Offer a very short reply. 1. What is the ratio of the Area (% of total land area) in Slovak Republic in 2007 to that in 2009?
Keep it short and to the point. 1. What is the ratio of the Area (% of total land area) of Japan in 2007 to that in 2010?
Provide a succinct answer. 1.01. What is the ratio of the Area (% of total land area) of Serbia in 2007 to that in 2010?
Your answer should be very brief. 1. What is the ratio of the Area (% of total land area) in Slovak Republic in 2007 to that in 2010?
Your answer should be compact. 0.99. What is the ratio of the Area (% of total land area) of Upper middle income in 2007 to that in 2011?
Ensure brevity in your answer.  1. What is the ratio of the Area (% of total land area) in Japan in 2007 to that in 2011?
Make the answer very short. 1.02. What is the ratio of the Area (% of total land area) of Serbia in 2007 to that in 2011?
Offer a terse response. 1. What is the ratio of the Area (% of total land area) in Upper middle income in 2007 to that in 2012?
Offer a terse response. 0.99. What is the ratio of the Area (% of total land area) in Japan in 2007 to that in 2012?
Make the answer very short. 1.02. What is the ratio of the Area (% of total land area) of Japan in 2007 to that in 2013?
Offer a very short reply. 1.03. What is the ratio of the Area (% of total land area) of Slovak Republic in 2007 to that in 2013?
Provide a succinct answer. 1. What is the ratio of the Area (% of total land area) in Upper middle income in 2008 to that in 2009?
Provide a succinct answer. 1. What is the ratio of the Area (% of total land area) in Serbia in 2008 to that in 2009?
Your answer should be very brief. 1. What is the ratio of the Area (% of total land area) of Slovak Republic in 2008 to that in 2009?
Provide a short and direct response. 1. What is the ratio of the Area (% of total land area) of Upper middle income in 2008 to that in 2010?
Your answer should be compact. 1. What is the ratio of the Area (% of total land area) in Japan in 2008 to that in 2010?
Your answer should be compact. 1.01. What is the ratio of the Area (% of total land area) of Serbia in 2008 to that in 2010?
Give a very brief answer. 1. What is the ratio of the Area (% of total land area) in Japan in 2008 to that in 2011?
Ensure brevity in your answer.  1.01. What is the ratio of the Area (% of total land area) in Japan in 2008 to that in 2012?
Ensure brevity in your answer.  1.02. What is the ratio of the Area (% of total land area) of Serbia in 2008 to that in 2012?
Give a very brief answer. 1. What is the ratio of the Area (% of total land area) in Upper middle income in 2008 to that in 2013?
Your response must be concise. 0.99. What is the ratio of the Area (% of total land area) in Japan in 2008 to that in 2013?
Your answer should be very brief. 1.02. What is the ratio of the Area (% of total land area) of Serbia in 2008 to that in 2013?
Offer a terse response. 1. What is the ratio of the Area (% of total land area) in Upper middle income in 2009 to that in 2010?
Offer a very short reply. 1. What is the ratio of the Area (% of total land area) of Serbia in 2009 to that in 2010?
Your answer should be very brief. 1. What is the ratio of the Area (% of total land area) of Slovak Republic in 2009 to that in 2010?
Keep it short and to the point. 0.99. What is the ratio of the Area (% of total land area) in Upper middle income in 2009 to that in 2011?
Your answer should be compact. 1. What is the ratio of the Area (% of total land area) in Japan in 2009 to that in 2011?
Make the answer very short. 1.01. What is the ratio of the Area (% of total land area) of Slovak Republic in 2009 to that in 2011?
Provide a short and direct response. 1. What is the ratio of the Area (% of total land area) in Upper middle income in 2009 to that in 2012?
Offer a very short reply. 0.99. What is the ratio of the Area (% of total land area) of Japan in 2009 to that in 2012?
Offer a terse response. 1.01. What is the ratio of the Area (% of total land area) in Serbia in 2009 to that in 2012?
Keep it short and to the point. 1. What is the ratio of the Area (% of total land area) in Upper middle income in 2009 to that in 2013?
Provide a short and direct response. 0.99. What is the ratio of the Area (% of total land area) of Japan in 2009 to that in 2013?
Keep it short and to the point. 1.02. What is the ratio of the Area (% of total land area) of Upper middle income in 2010 to that in 2011?
Offer a very short reply. 1. What is the ratio of the Area (% of total land area) in Japan in 2010 to that in 2011?
Give a very brief answer. 1.01. What is the ratio of the Area (% of total land area) of Slovak Republic in 2010 to that in 2011?
Make the answer very short. 1.01. What is the ratio of the Area (% of total land area) in Upper middle income in 2010 to that in 2012?
Your answer should be very brief. 1. What is the ratio of the Area (% of total land area) of Japan in 2010 to that in 2012?
Make the answer very short. 1.01. What is the ratio of the Area (% of total land area) of Slovak Republic in 2010 to that in 2012?
Give a very brief answer. 1.01. What is the ratio of the Area (% of total land area) in Upper middle income in 2010 to that in 2013?
Offer a terse response. 0.99. What is the ratio of the Area (% of total land area) in Japan in 2010 to that in 2013?
Give a very brief answer. 1.01. What is the ratio of the Area (% of total land area) of Slovak Republic in 2010 to that in 2013?
Keep it short and to the point. 1.01. What is the ratio of the Area (% of total land area) of Japan in 2011 to that in 2012?
Your answer should be compact. 1. What is the ratio of the Area (% of total land area) in Japan in 2011 to that in 2013?
Give a very brief answer. 1.01. What is the ratio of the Area (% of total land area) of Serbia in 2011 to that in 2013?
Offer a very short reply. 1. What is the ratio of the Area (% of total land area) of Upper middle income in 2012 to that in 2013?
Offer a terse response. 1. What is the ratio of the Area (% of total land area) of Japan in 2012 to that in 2013?
Give a very brief answer. 1. What is the ratio of the Area (% of total land area) of Serbia in 2012 to that in 2013?
Offer a very short reply. 1. What is the difference between the highest and the second highest Area (% of total land area) of Upper middle income?
Provide a succinct answer. 0.15. What is the difference between the highest and the second highest Area (% of total land area) in Japan?
Your response must be concise. 0.06. What is the difference between the highest and the second highest Area (% of total land area) in Serbia?
Your response must be concise. 0.09. What is the difference between the highest and the second highest Area (% of total land area) of Slovak Republic?
Ensure brevity in your answer.  0.17. What is the difference between the highest and the lowest Area (% of total land area) of Upper middle income?
Your response must be concise. 0.43. What is the difference between the highest and the lowest Area (% of total land area) in Japan?
Offer a very short reply. 0.31. What is the difference between the highest and the lowest Area (% of total land area) of Serbia?
Your response must be concise. 0.22. What is the difference between the highest and the lowest Area (% of total land area) of Slovak Republic?
Offer a terse response. 0.36. 